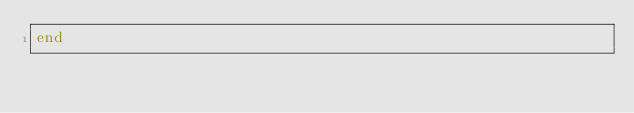Convert code to text. <code><loc_0><loc_0><loc_500><loc_500><_Julia_>end
</code> 